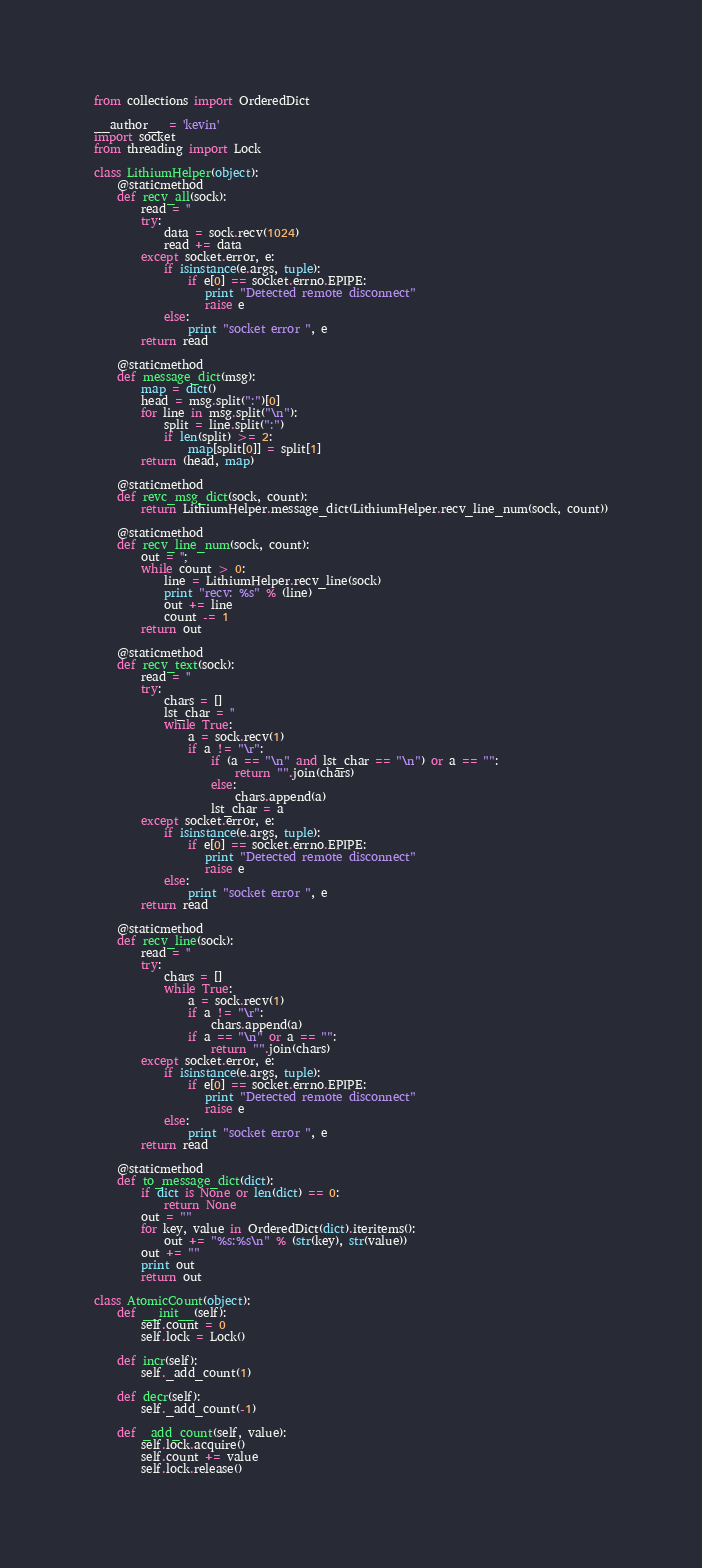Convert code to text. <code><loc_0><loc_0><loc_500><loc_500><_Python_>from collections import OrderedDict

__author__ = 'kevin'
import socket
from threading import Lock

class LithiumHelper(object):
    @staticmethod
    def recv_all(sock):
        read = ''
        try:
            data = sock.recv(1024)
            read += data
        except socket.error, e:
            if isinstance(e.args, tuple):
                if e[0] == socket.errno.EPIPE:
                   print "Detected remote disconnect"
                   raise e
            else:
                print "socket error ", e
        return read

    @staticmethod
    def message_dict(msg):
        map = dict()
        head = msg.split(":")[0]
        for line in msg.split("\n"):
            split = line.split(":")
            if len(split) >= 2:
                map[split[0]] = split[1]
        return (head, map)

    @staticmethod
    def revc_msg_dict(sock, count):
        return LithiumHelper.message_dict(LithiumHelper.recv_line_num(sock, count))

    @staticmethod
    def recv_line_num(sock, count):
        out = '';
        while count > 0:
            line = LithiumHelper.recv_line(sock)
            print "recv: %s" % (line)
            out += line
            count -= 1
        return out

    @staticmethod
    def recv_text(sock):
        read = ''
        try:
            chars = []
            lst_char = ''
            while True:
                a = sock.recv(1)
                if a != "\r":
                    if (a == "\n" and lst_char == "\n") or a == "":
                        return "".join(chars)
                    else:
                        chars.append(a)
                    lst_char = a
        except socket.error, e:
            if isinstance(e.args, tuple):
                if e[0] == socket.errno.EPIPE:
                   print "Detected remote disconnect"
                   raise e
            else:
                print "socket error ", e
        return read

    @staticmethod
    def recv_line(sock):
        read = ''
        try:
            chars = []
            while True:
                a = sock.recv(1)
                if a != "\r":
                    chars.append(a)
                if a == "\n" or a == "":
                    return "".join(chars)
        except socket.error, e:
            if isinstance(e.args, tuple):
                if e[0] == socket.errno.EPIPE:
                   print "Detected remote disconnect"
                   raise e
            else:
                print "socket error ", e
        return read

    @staticmethod
    def to_message_dict(dict):
        if dict is None or len(dict) == 0:
            return None
        out = ""
        for key, value in OrderedDict(dict).iteritems():
            out += "%s:%s\n" % (str(key), str(value))
        out += ""
        print out
        return out

class AtomicCount(object):
    def __init__(self):
        self.count = 0
        self.lock = Lock()

    def incr(self):
        self._add_count(1)

    def decr(self):
        self._add_count(-1)

    def _add_count(self, value):
        self.lock.acquire()
        self.count += value
        self.lock.release()
</code> 